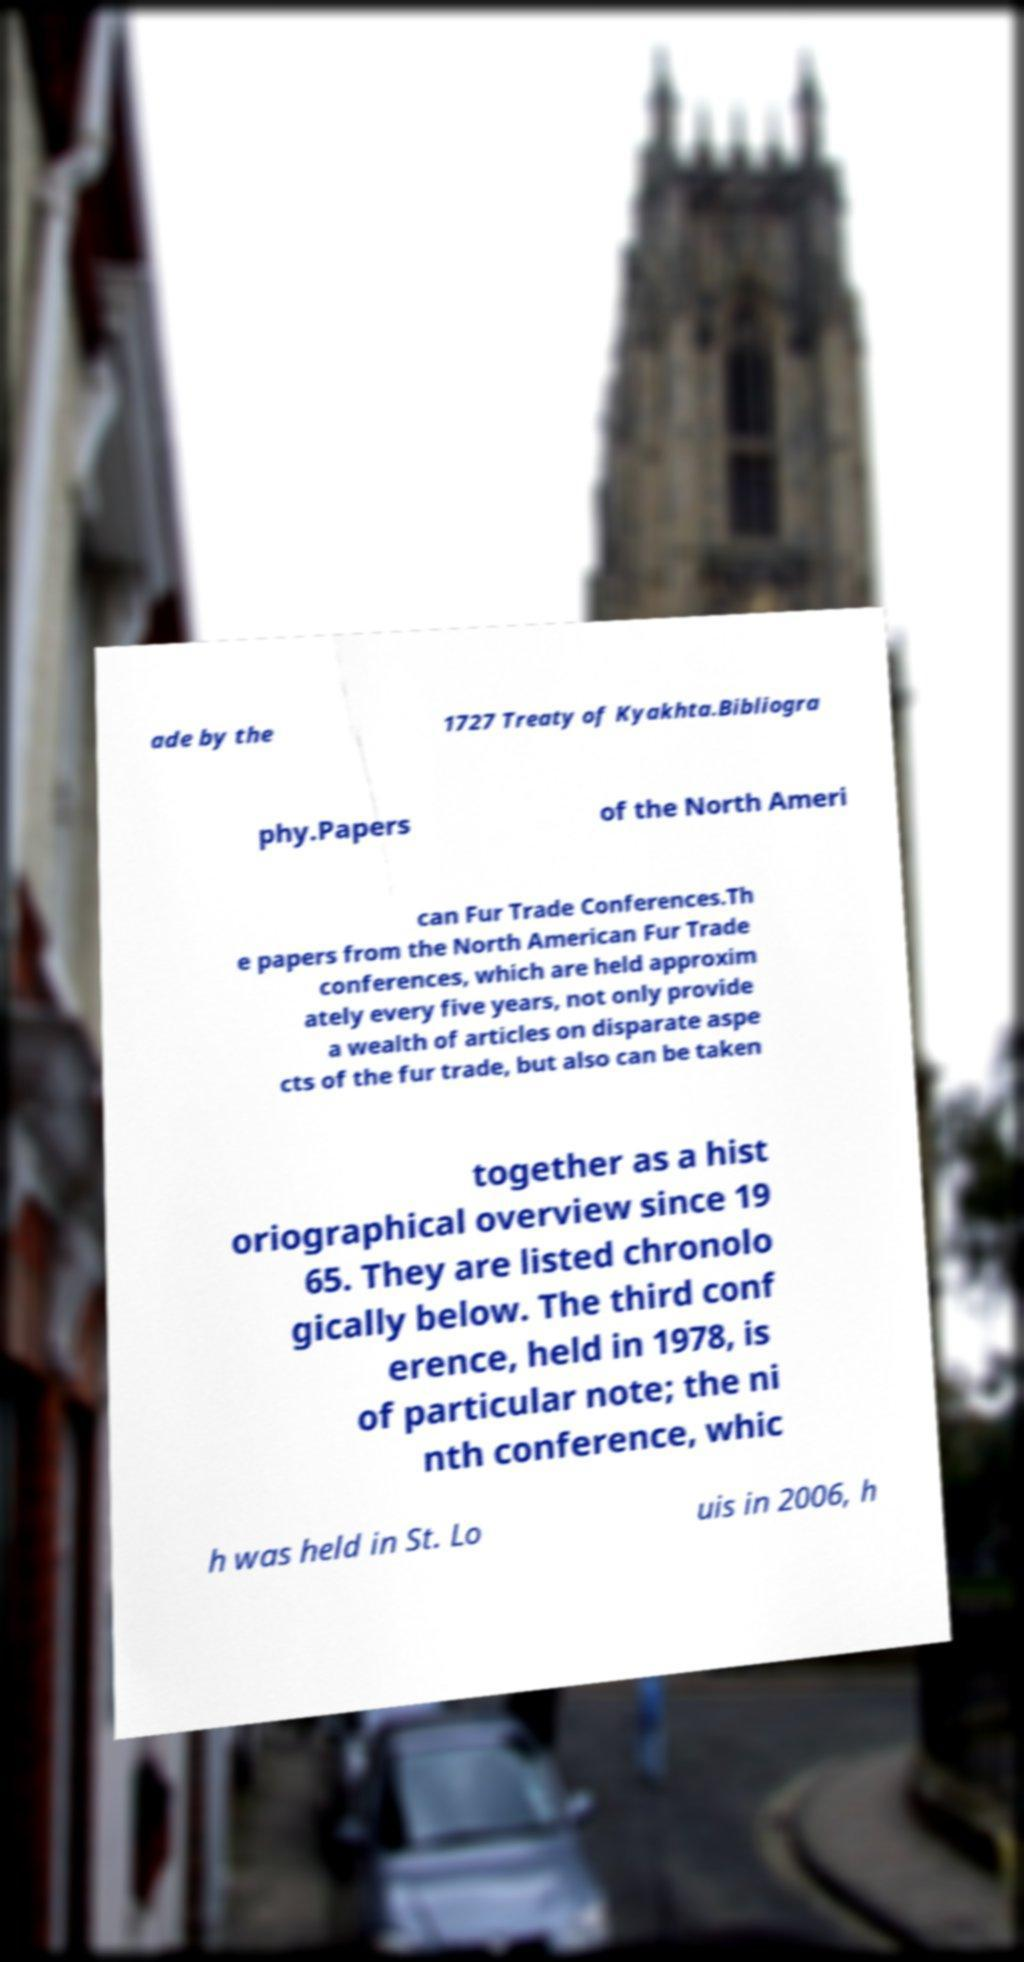Could you extract and type out the text from this image? ade by the 1727 Treaty of Kyakhta.Bibliogra phy.Papers of the North Ameri can Fur Trade Conferences.Th e papers from the North American Fur Trade conferences, which are held approxim ately every five years, not only provide a wealth of articles on disparate aspe cts of the fur trade, but also can be taken together as a hist oriographical overview since 19 65. They are listed chronolo gically below. The third conf erence, held in 1978, is of particular note; the ni nth conference, whic h was held in St. Lo uis in 2006, h 